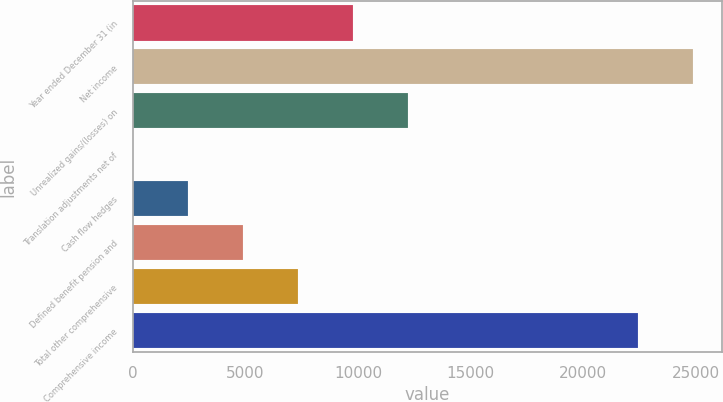Convert chart. <chart><loc_0><loc_0><loc_500><loc_500><bar_chart><fcel>Year ended December 31 (in<fcel>Net income<fcel>Unrealized gains/(losses) on<fcel>Translation adjustments net of<fcel>Cash flow hedges<fcel>Defined benefit pension and<fcel>Total other comprehensive<fcel>Comprehensive income<nl><fcel>9785.8<fcel>24887.7<fcel>12228.5<fcel>15<fcel>2457.7<fcel>4900.4<fcel>7343.1<fcel>22445<nl></chart> 